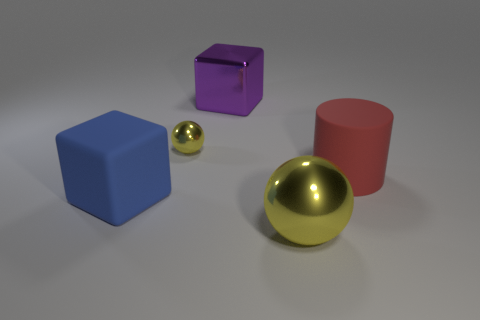How big is the object that is both in front of the large purple metallic object and behind the big red object?
Offer a terse response. Small. What is the yellow thing to the right of the purple cube made of?
Your answer should be very brief. Metal. Are there any other things of the same shape as the tiny metallic thing?
Give a very brief answer. Yes. How many other blue objects are the same shape as the tiny metallic thing?
Offer a very short reply. 0. Do the yellow thing that is in front of the red rubber thing and the matte thing to the left of the metallic cube have the same size?
Ensure brevity in your answer.  Yes. What shape is the big red matte object that is right of the large block on the right side of the small thing?
Give a very brief answer. Cylinder. Is the number of red cylinders in front of the large purple shiny block the same as the number of big blue rubber cubes?
Offer a terse response. Yes. The yellow sphere to the left of the cube that is to the right of the yellow metal thing left of the large metal cube is made of what material?
Offer a very short reply. Metal. Is there a yellow sphere of the same size as the purple metallic cube?
Provide a short and direct response. Yes. What is the shape of the tiny yellow object?
Your response must be concise. Sphere. 